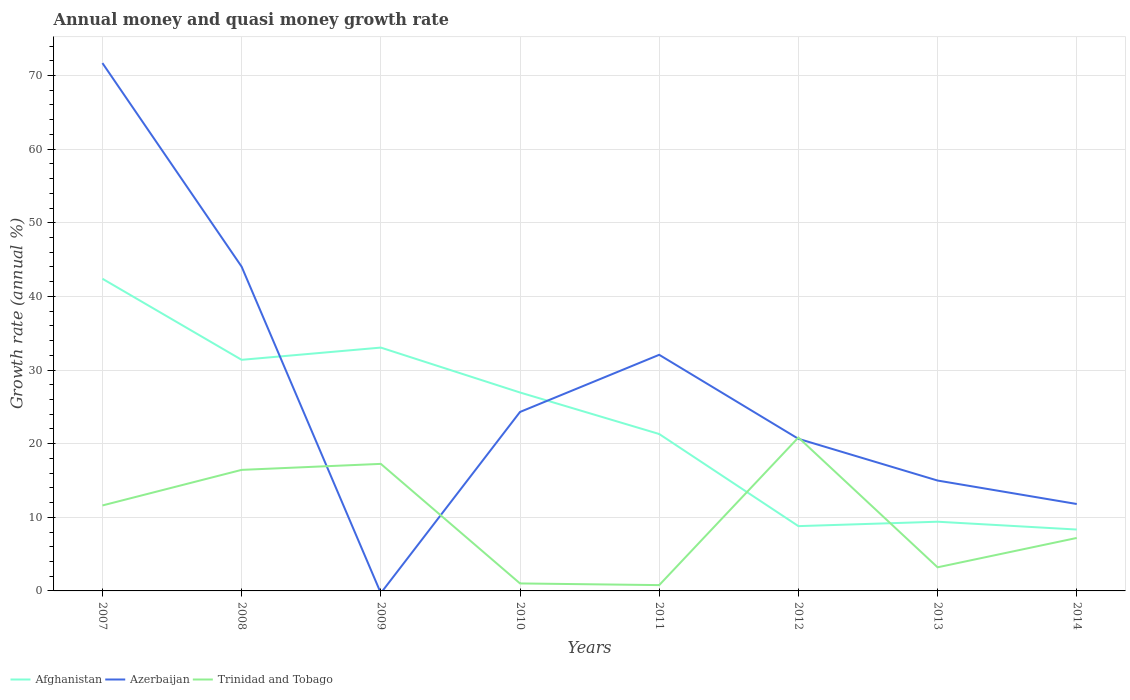Does the line corresponding to Trinidad and Tobago intersect with the line corresponding to Afghanistan?
Ensure brevity in your answer.  Yes. Is the number of lines equal to the number of legend labels?
Give a very brief answer. No. What is the total growth rate in Trinidad and Tobago in the graph?
Your answer should be very brief. -4.83. What is the difference between the highest and the second highest growth rate in Trinidad and Tobago?
Provide a short and direct response. 20.04. What is the difference between the highest and the lowest growth rate in Trinidad and Tobago?
Your answer should be very brief. 4. What is the difference between two consecutive major ticks on the Y-axis?
Keep it short and to the point. 10. Are the values on the major ticks of Y-axis written in scientific E-notation?
Keep it short and to the point. No. Does the graph contain any zero values?
Your answer should be compact. Yes. Where does the legend appear in the graph?
Offer a very short reply. Bottom left. What is the title of the graph?
Your answer should be very brief. Annual money and quasi money growth rate. What is the label or title of the X-axis?
Keep it short and to the point. Years. What is the label or title of the Y-axis?
Ensure brevity in your answer.  Growth rate (annual %). What is the Growth rate (annual %) in Afghanistan in 2007?
Offer a very short reply. 42.4. What is the Growth rate (annual %) in Azerbaijan in 2007?
Provide a short and direct response. 71.68. What is the Growth rate (annual %) in Trinidad and Tobago in 2007?
Your answer should be very brief. 11.61. What is the Growth rate (annual %) of Afghanistan in 2008?
Your answer should be very brief. 31.38. What is the Growth rate (annual %) of Azerbaijan in 2008?
Provide a succinct answer. 44.04. What is the Growth rate (annual %) of Trinidad and Tobago in 2008?
Ensure brevity in your answer.  16.44. What is the Growth rate (annual %) of Afghanistan in 2009?
Your answer should be compact. 33.05. What is the Growth rate (annual %) of Trinidad and Tobago in 2009?
Offer a terse response. 17.25. What is the Growth rate (annual %) in Afghanistan in 2010?
Ensure brevity in your answer.  26.95. What is the Growth rate (annual %) in Azerbaijan in 2010?
Provide a succinct answer. 24.3. What is the Growth rate (annual %) in Trinidad and Tobago in 2010?
Keep it short and to the point. 1.02. What is the Growth rate (annual %) of Afghanistan in 2011?
Ensure brevity in your answer.  21.31. What is the Growth rate (annual %) in Azerbaijan in 2011?
Offer a very short reply. 32.07. What is the Growth rate (annual %) in Trinidad and Tobago in 2011?
Your answer should be very brief. 0.79. What is the Growth rate (annual %) of Afghanistan in 2012?
Give a very brief answer. 8.8. What is the Growth rate (annual %) of Azerbaijan in 2012?
Give a very brief answer. 20.66. What is the Growth rate (annual %) of Trinidad and Tobago in 2012?
Offer a terse response. 20.83. What is the Growth rate (annual %) of Afghanistan in 2013?
Ensure brevity in your answer.  9.4. What is the Growth rate (annual %) in Azerbaijan in 2013?
Your response must be concise. 14.99. What is the Growth rate (annual %) in Trinidad and Tobago in 2013?
Provide a succinct answer. 3.21. What is the Growth rate (annual %) in Afghanistan in 2014?
Provide a succinct answer. 8.34. What is the Growth rate (annual %) in Azerbaijan in 2014?
Keep it short and to the point. 11.8. What is the Growth rate (annual %) of Trinidad and Tobago in 2014?
Give a very brief answer. 7.2. Across all years, what is the maximum Growth rate (annual %) of Afghanistan?
Your answer should be compact. 42.4. Across all years, what is the maximum Growth rate (annual %) in Azerbaijan?
Offer a terse response. 71.68. Across all years, what is the maximum Growth rate (annual %) of Trinidad and Tobago?
Your answer should be very brief. 20.83. Across all years, what is the minimum Growth rate (annual %) of Afghanistan?
Your response must be concise. 8.34. Across all years, what is the minimum Growth rate (annual %) of Trinidad and Tobago?
Your response must be concise. 0.79. What is the total Growth rate (annual %) of Afghanistan in the graph?
Your response must be concise. 181.61. What is the total Growth rate (annual %) in Azerbaijan in the graph?
Your response must be concise. 219.54. What is the total Growth rate (annual %) in Trinidad and Tobago in the graph?
Offer a terse response. 78.34. What is the difference between the Growth rate (annual %) of Afghanistan in 2007 and that in 2008?
Offer a terse response. 11.01. What is the difference between the Growth rate (annual %) in Azerbaijan in 2007 and that in 2008?
Provide a succinct answer. 27.65. What is the difference between the Growth rate (annual %) in Trinidad and Tobago in 2007 and that in 2008?
Offer a terse response. -4.83. What is the difference between the Growth rate (annual %) in Afghanistan in 2007 and that in 2009?
Make the answer very short. 9.35. What is the difference between the Growth rate (annual %) in Trinidad and Tobago in 2007 and that in 2009?
Ensure brevity in your answer.  -5.65. What is the difference between the Growth rate (annual %) of Afghanistan in 2007 and that in 2010?
Provide a short and direct response. 15.45. What is the difference between the Growth rate (annual %) in Azerbaijan in 2007 and that in 2010?
Offer a very short reply. 47.38. What is the difference between the Growth rate (annual %) of Trinidad and Tobago in 2007 and that in 2010?
Offer a terse response. 10.59. What is the difference between the Growth rate (annual %) in Afghanistan in 2007 and that in 2011?
Give a very brief answer. 21.09. What is the difference between the Growth rate (annual %) in Azerbaijan in 2007 and that in 2011?
Your answer should be compact. 39.62. What is the difference between the Growth rate (annual %) in Trinidad and Tobago in 2007 and that in 2011?
Your response must be concise. 10.82. What is the difference between the Growth rate (annual %) in Afghanistan in 2007 and that in 2012?
Your response must be concise. 33.6. What is the difference between the Growth rate (annual %) in Azerbaijan in 2007 and that in 2012?
Your answer should be compact. 51.03. What is the difference between the Growth rate (annual %) in Trinidad and Tobago in 2007 and that in 2012?
Offer a very short reply. -9.22. What is the difference between the Growth rate (annual %) in Afghanistan in 2007 and that in 2013?
Offer a terse response. 33. What is the difference between the Growth rate (annual %) in Azerbaijan in 2007 and that in 2013?
Make the answer very short. 56.69. What is the difference between the Growth rate (annual %) in Afghanistan in 2007 and that in 2014?
Offer a terse response. 34.06. What is the difference between the Growth rate (annual %) of Azerbaijan in 2007 and that in 2014?
Provide a short and direct response. 59.88. What is the difference between the Growth rate (annual %) in Trinidad and Tobago in 2007 and that in 2014?
Make the answer very short. 4.41. What is the difference between the Growth rate (annual %) in Afghanistan in 2008 and that in 2009?
Ensure brevity in your answer.  -1.66. What is the difference between the Growth rate (annual %) in Trinidad and Tobago in 2008 and that in 2009?
Give a very brief answer. -0.82. What is the difference between the Growth rate (annual %) in Afghanistan in 2008 and that in 2010?
Ensure brevity in your answer.  4.44. What is the difference between the Growth rate (annual %) of Azerbaijan in 2008 and that in 2010?
Make the answer very short. 19.73. What is the difference between the Growth rate (annual %) of Trinidad and Tobago in 2008 and that in 2010?
Keep it short and to the point. 15.42. What is the difference between the Growth rate (annual %) of Afghanistan in 2008 and that in 2011?
Offer a very short reply. 10.07. What is the difference between the Growth rate (annual %) in Azerbaijan in 2008 and that in 2011?
Give a very brief answer. 11.97. What is the difference between the Growth rate (annual %) in Trinidad and Tobago in 2008 and that in 2011?
Give a very brief answer. 15.65. What is the difference between the Growth rate (annual %) of Afghanistan in 2008 and that in 2012?
Your response must be concise. 22.58. What is the difference between the Growth rate (annual %) of Azerbaijan in 2008 and that in 2012?
Ensure brevity in your answer.  23.38. What is the difference between the Growth rate (annual %) of Trinidad and Tobago in 2008 and that in 2012?
Your answer should be very brief. -4.39. What is the difference between the Growth rate (annual %) in Afghanistan in 2008 and that in 2013?
Your answer should be compact. 21.99. What is the difference between the Growth rate (annual %) in Azerbaijan in 2008 and that in 2013?
Ensure brevity in your answer.  29.05. What is the difference between the Growth rate (annual %) in Trinidad and Tobago in 2008 and that in 2013?
Offer a very short reply. 13.23. What is the difference between the Growth rate (annual %) of Afghanistan in 2008 and that in 2014?
Give a very brief answer. 23.05. What is the difference between the Growth rate (annual %) of Azerbaijan in 2008 and that in 2014?
Give a very brief answer. 32.23. What is the difference between the Growth rate (annual %) of Trinidad and Tobago in 2008 and that in 2014?
Your response must be concise. 9.24. What is the difference between the Growth rate (annual %) of Afghanistan in 2009 and that in 2010?
Make the answer very short. 6.1. What is the difference between the Growth rate (annual %) of Trinidad and Tobago in 2009 and that in 2010?
Keep it short and to the point. 16.24. What is the difference between the Growth rate (annual %) in Afghanistan in 2009 and that in 2011?
Give a very brief answer. 11.74. What is the difference between the Growth rate (annual %) in Trinidad and Tobago in 2009 and that in 2011?
Offer a terse response. 16.46. What is the difference between the Growth rate (annual %) of Afghanistan in 2009 and that in 2012?
Your answer should be very brief. 24.25. What is the difference between the Growth rate (annual %) in Trinidad and Tobago in 2009 and that in 2012?
Give a very brief answer. -3.58. What is the difference between the Growth rate (annual %) in Afghanistan in 2009 and that in 2013?
Your answer should be compact. 23.65. What is the difference between the Growth rate (annual %) of Trinidad and Tobago in 2009 and that in 2013?
Your answer should be compact. 14.05. What is the difference between the Growth rate (annual %) in Afghanistan in 2009 and that in 2014?
Offer a very short reply. 24.71. What is the difference between the Growth rate (annual %) in Trinidad and Tobago in 2009 and that in 2014?
Make the answer very short. 10.06. What is the difference between the Growth rate (annual %) of Afghanistan in 2010 and that in 2011?
Make the answer very short. 5.64. What is the difference between the Growth rate (annual %) of Azerbaijan in 2010 and that in 2011?
Ensure brevity in your answer.  -7.76. What is the difference between the Growth rate (annual %) in Trinidad and Tobago in 2010 and that in 2011?
Ensure brevity in your answer.  0.23. What is the difference between the Growth rate (annual %) of Afghanistan in 2010 and that in 2012?
Provide a short and direct response. 18.15. What is the difference between the Growth rate (annual %) in Azerbaijan in 2010 and that in 2012?
Ensure brevity in your answer.  3.65. What is the difference between the Growth rate (annual %) in Trinidad and Tobago in 2010 and that in 2012?
Your response must be concise. -19.82. What is the difference between the Growth rate (annual %) of Afghanistan in 2010 and that in 2013?
Ensure brevity in your answer.  17.55. What is the difference between the Growth rate (annual %) of Azerbaijan in 2010 and that in 2013?
Your answer should be compact. 9.31. What is the difference between the Growth rate (annual %) of Trinidad and Tobago in 2010 and that in 2013?
Ensure brevity in your answer.  -2.19. What is the difference between the Growth rate (annual %) in Afghanistan in 2010 and that in 2014?
Provide a succinct answer. 18.61. What is the difference between the Growth rate (annual %) of Azerbaijan in 2010 and that in 2014?
Keep it short and to the point. 12.5. What is the difference between the Growth rate (annual %) of Trinidad and Tobago in 2010 and that in 2014?
Your answer should be compact. -6.18. What is the difference between the Growth rate (annual %) of Afghanistan in 2011 and that in 2012?
Give a very brief answer. 12.51. What is the difference between the Growth rate (annual %) of Azerbaijan in 2011 and that in 2012?
Make the answer very short. 11.41. What is the difference between the Growth rate (annual %) of Trinidad and Tobago in 2011 and that in 2012?
Make the answer very short. -20.04. What is the difference between the Growth rate (annual %) in Afghanistan in 2011 and that in 2013?
Offer a terse response. 11.91. What is the difference between the Growth rate (annual %) of Azerbaijan in 2011 and that in 2013?
Offer a very short reply. 17.08. What is the difference between the Growth rate (annual %) of Trinidad and Tobago in 2011 and that in 2013?
Provide a succinct answer. -2.42. What is the difference between the Growth rate (annual %) of Afghanistan in 2011 and that in 2014?
Your response must be concise. 12.97. What is the difference between the Growth rate (annual %) of Azerbaijan in 2011 and that in 2014?
Your answer should be compact. 20.26. What is the difference between the Growth rate (annual %) of Trinidad and Tobago in 2011 and that in 2014?
Give a very brief answer. -6.41. What is the difference between the Growth rate (annual %) in Afghanistan in 2012 and that in 2013?
Give a very brief answer. -0.6. What is the difference between the Growth rate (annual %) in Azerbaijan in 2012 and that in 2013?
Provide a succinct answer. 5.67. What is the difference between the Growth rate (annual %) in Trinidad and Tobago in 2012 and that in 2013?
Your response must be concise. 17.62. What is the difference between the Growth rate (annual %) in Afghanistan in 2012 and that in 2014?
Ensure brevity in your answer.  0.46. What is the difference between the Growth rate (annual %) in Azerbaijan in 2012 and that in 2014?
Offer a very short reply. 8.86. What is the difference between the Growth rate (annual %) of Trinidad and Tobago in 2012 and that in 2014?
Offer a very short reply. 13.64. What is the difference between the Growth rate (annual %) of Afghanistan in 2013 and that in 2014?
Provide a succinct answer. 1.06. What is the difference between the Growth rate (annual %) of Azerbaijan in 2013 and that in 2014?
Your answer should be very brief. 3.19. What is the difference between the Growth rate (annual %) of Trinidad and Tobago in 2013 and that in 2014?
Your response must be concise. -3.99. What is the difference between the Growth rate (annual %) of Afghanistan in 2007 and the Growth rate (annual %) of Azerbaijan in 2008?
Your answer should be compact. -1.64. What is the difference between the Growth rate (annual %) of Afghanistan in 2007 and the Growth rate (annual %) of Trinidad and Tobago in 2008?
Ensure brevity in your answer.  25.96. What is the difference between the Growth rate (annual %) in Azerbaijan in 2007 and the Growth rate (annual %) in Trinidad and Tobago in 2008?
Keep it short and to the point. 55.25. What is the difference between the Growth rate (annual %) in Afghanistan in 2007 and the Growth rate (annual %) in Trinidad and Tobago in 2009?
Keep it short and to the point. 25.14. What is the difference between the Growth rate (annual %) in Azerbaijan in 2007 and the Growth rate (annual %) in Trinidad and Tobago in 2009?
Give a very brief answer. 54.43. What is the difference between the Growth rate (annual %) of Afghanistan in 2007 and the Growth rate (annual %) of Azerbaijan in 2010?
Offer a very short reply. 18.09. What is the difference between the Growth rate (annual %) in Afghanistan in 2007 and the Growth rate (annual %) in Trinidad and Tobago in 2010?
Ensure brevity in your answer.  41.38. What is the difference between the Growth rate (annual %) in Azerbaijan in 2007 and the Growth rate (annual %) in Trinidad and Tobago in 2010?
Your answer should be compact. 70.67. What is the difference between the Growth rate (annual %) in Afghanistan in 2007 and the Growth rate (annual %) in Azerbaijan in 2011?
Offer a very short reply. 10.33. What is the difference between the Growth rate (annual %) of Afghanistan in 2007 and the Growth rate (annual %) of Trinidad and Tobago in 2011?
Make the answer very short. 41.61. What is the difference between the Growth rate (annual %) of Azerbaijan in 2007 and the Growth rate (annual %) of Trinidad and Tobago in 2011?
Your response must be concise. 70.89. What is the difference between the Growth rate (annual %) of Afghanistan in 2007 and the Growth rate (annual %) of Azerbaijan in 2012?
Provide a short and direct response. 21.74. What is the difference between the Growth rate (annual %) in Afghanistan in 2007 and the Growth rate (annual %) in Trinidad and Tobago in 2012?
Provide a succinct answer. 21.56. What is the difference between the Growth rate (annual %) of Azerbaijan in 2007 and the Growth rate (annual %) of Trinidad and Tobago in 2012?
Give a very brief answer. 50.85. What is the difference between the Growth rate (annual %) of Afghanistan in 2007 and the Growth rate (annual %) of Azerbaijan in 2013?
Make the answer very short. 27.41. What is the difference between the Growth rate (annual %) of Afghanistan in 2007 and the Growth rate (annual %) of Trinidad and Tobago in 2013?
Offer a terse response. 39.19. What is the difference between the Growth rate (annual %) in Azerbaijan in 2007 and the Growth rate (annual %) in Trinidad and Tobago in 2013?
Provide a short and direct response. 68.48. What is the difference between the Growth rate (annual %) in Afghanistan in 2007 and the Growth rate (annual %) in Azerbaijan in 2014?
Your response must be concise. 30.59. What is the difference between the Growth rate (annual %) in Afghanistan in 2007 and the Growth rate (annual %) in Trinidad and Tobago in 2014?
Offer a terse response. 35.2. What is the difference between the Growth rate (annual %) of Azerbaijan in 2007 and the Growth rate (annual %) of Trinidad and Tobago in 2014?
Your answer should be compact. 64.49. What is the difference between the Growth rate (annual %) in Afghanistan in 2008 and the Growth rate (annual %) in Trinidad and Tobago in 2009?
Make the answer very short. 14.13. What is the difference between the Growth rate (annual %) of Azerbaijan in 2008 and the Growth rate (annual %) of Trinidad and Tobago in 2009?
Offer a terse response. 26.78. What is the difference between the Growth rate (annual %) in Afghanistan in 2008 and the Growth rate (annual %) in Azerbaijan in 2010?
Offer a terse response. 7.08. What is the difference between the Growth rate (annual %) of Afghanistan in 2008 and the Growth rate (annual %) of Trinidad and Tobago in 2010?
Give a very brief answer. 30.37. What is the difference between the Growth rate (annual %) of Azerbaijan in 2008 and the Growth rate (annual %) of Trinidad and Tobago in 2010?
Provide a succinct answer. 43.02. What is the difference between the Growth rate (annual %) in Afghanistan in 2008 and the Growth rate (annual %) in Azerbaijan in 2011?
Your answer should be very brief. -0.68. What is the difference between the Growth rate (annual %) in Afghanistan in 2008 and the Growth rate (annual %) in Trinidad and Tobago in 2011?
Provide a short and direct response. 30.59. What is the difference between the Growth rate (annual %) of Azerbaijan in 2008 and the Growth rate (annual %) of Trinidad and Tobago in 2011?
Your answer should be compact. 43.25. What is the difference between the Growth rate (annual %) in Afghanistan in 2008 and the Growth rate (annual %) in Azerbaijan in 2012?
Provide a succinct answer. 10.73. What is the difference between the Growth rate (annual %) in Afghanistan in 2008 and the Growth rate (annual %) in Trinidad and Tobago in 2012?
Make the answer very short. 10.55. What is the difference between the Growth rate (annual %) of Azerbaijan in 2008 and the Growth rate (annual %) of Trinidad and Tobago in 2012?
Your answer should be very brief. 23.2. What is the difference between the Growth rate (annual %) in Afghanistan in 2008 and the Growth rate (annual %) in Azerbaijan in 2013?
Your answer should be very brief. 16.39. What is the difference between the Growth rate (annual %) in Afghanistan in 2008 and the Growth rate (annual %) in Trinidad and Tobago in 2013?
Provide a succinct answer. 28.18. What is the difference between the Growth rate (annual %) in Azerbaijan in 2008 and the Growth rate (annual %) in Trinidad and Tobago in 2013?
Your response must be concise. 40.83. What is the difference between the Growth rate (annual %) of Afghanistan in 2008 and the Growth rate (annual %) of Azerbaijan in 2014?
Your answer should be very brief. 19.58. What is the difference between the Growth rate (annual %) of Afghanistan in 2008 and the Growth rate (annual %) of Trinidad and Tobago in 2014?
Your response must be concise. 24.19. What is the difference between the Growth rate (annual %) in Azerbaijan in 2008 and the Growth rate (annual %) in Trinidad and Tobago in 2014?
Your response must be concise. 36.84. What is the difference between the Growth rate (annual %) of Afghanistan in 2009 and the Growth rate (annual %) of Azerbaijan in 2010?
Ensure brevity in your answer.  8.74. What is the difference between the Growth rate (annual %) of Afghanistan in 2009 and the Growth rate (annual %) of Trinidad and Tobago in 2010?
Offer a very short reply. 32.03. What is the difference between the Growth rate (annual %) in Afghanistan in 2009 and the Growth rate (annual %) in Azerbaijan in 2011?
Make the answer very short. 0.98. What is the difference between the Growth rate (annual %) of Afghanistan in 2009 and the Growth rate (annual %) of Trinidad and Tobago in 2011?
Offer a terse response. 32.26. What is the difference between the Growth rate (annual %) of Afghanistan in 2009 and the Growth rate (annual %) of Azerbaijan in 2012?
Your answer should be very brief. 12.39. What is the difference between the Growth rate (annual %) in Afghanistan in 2009 and the Growth rate (annual %) in Trinidad and Tobago in 2012?
Ensure brevity in your answer.  12.21. What is the difference between the Growth rate (annual %) of Afghanistan in 2009 and the Growth rate (annual %) of Azerbaijan in 2013?
Your response must be concise. 18.06. What is the difference between the Growth rate (annual %) in Afghanistan in 2009 and the Growth rate (annual %) in Trinidad and Tobago in 2013?
Ensure brevity in your answer.  29.84. What is the difference between the Growth rate (annual %) in Afghanistan in 2009 and the Growth rate (annual %) in Azerbaijan in 2014?
Provide a short and direct response. 21.24. What is the difference between the Growth rate (annual %) in Afghanistan in 2009 and the Growth rate (annual %) in Trinidad and Tobago in 2014?
Your answer should be compact. 25.85. What is the difference between the Growth rate (annual %) in Afghanistan in 2010 and the Growth rate (annual %) in Azerbaijan in 2011?
Your answer should be very brief. -5.12. What is the difference between the Growth rate (annual %) in Afghanistan in 2010 and the Growth rate (annual %) in Trinidad and Tobago in 2011?
Provide a succinct answer. 26.16. What is the difference between the Growth rate (annual %) of Azerbaijan in 2010 and the Growth rate (annual %) of Trinidad and Tobago in 2011?
Make the answer very short. 23.51. What is the difference between the Growth rate (annual %) of Afghanistan in 2010 and the Growth rate (annual %) of Azerbaijan in 2012?
Provide a succinct answer. 6.29. What is the difference between the Growth rate (annual %) in Afghanistan in 2010 and the Growth rate (annual %) in Trinidad and Tobago in 2012?
Offer a terse response. 6.11. What is the difference between the Growth rate (annual %) in Azerbaijan in 2010 and the Growth rate (annual %) in Trinidad and Tobago in 2012?
Your response must be concise. 3.47. What is the difference between the Growth rate (annual %) of Afghanistan in 2010 and the Growth rate (annual %) of Azerbaijan in 2013?
Ensure brevity in your answer.  11.96. What is the difference between the Growth rate (annual %) of Afghanistan in 2010 and the Growth rate (annual %) of Trinidad and Tobago in 2013?
Your answer should be compact. 23.74. What is the difference between the Growth rate (annual %) of Azerbaijan in 2010 and the Growth rate (annual %) of Trinidad and Tobago in 2013?
Provide a succinct answer. 21.1. What is the difference between the Growth rate (annual %) in Afghanistan in 2010 and the Growth rate (annual %) in Azerbaijan in 2014?
Your answer should be compact. 15.14. What is the difference between the Growth rate (annual %) of Afghanistan in 2010 and the Growth rate (annual %) of Trinidad and Tobago in 2014?
Provide a succinct answer. 19.75. What is the difference between the Growth rate (annual %) of Azerbaijan in 2010 and the Growth rate (annual %) of Trinidad and Tobago in 2014?
Ensure brevity in your answer.  17.11. What is the difference between the Growth rate (annual %) of Afghanistan in 2011 and the Growth rate (annual %) of Azerbaijan in 2012?
Offer a very short reply. 0.65. What is the difference between the Growth rate (annual %) in Afghanistan in 2011 and the Growth rate (annual %) in Trinidad and Tobago in 2012?
Make the answer very short. 0.48. What is the difference between the Growth rate (annual %) in Azerbaijan in 2011 and the Growth rate (annual %) in Trinidad and Tobago in 2012?
Your answer should be very brief. 11.23. What is the difference between the Growth rate (annual %) in Afghanistan in 2011 and the Growth rate (annual %) in Azerbaijan in 2013?
Your response must be concise. 6.32. What is the difference between the Growth rate (annual %) of Afghanistan in 2011 and the Growth rate (annual %) of Trinidad and Tobago in 2013?
Offer a terse response. 18.1. What is the difference between the Growth rate (annual %) of Azerbaijan in 2011 and the Growth rate (annual %) of Trinidad and Tobago in 2013?
Your answer should be very brief. 28.86. What is the difference between the Growth rate (annual %) in Afghanistan in 2011 and the Growth rate (annual %) in Azerbaijan in 2014?
Offer a terse response. 9.51. What is the difference between the Growth rate (annual %) of Afghanistan in 2011 and the Growth rate (annual %) of Trinidad and Tobago in 2014?
Keep it short and to the point. 14.11. What is the difference between the Growth rate (annual %) in Azerbaijan in 2011 and the Growth rate (annual %) in Trinidad and Tobago in 2014?
Ensure brevity in your answer.  24.87. What is the difference between the Growth rate (annual %) of Afghanistan in 2012 and the Growth rate (annual %) of Azerbaijan in 2013?
Your answer should be compact. -6.19. What is the difference between the Growth rate (annual %) of Afghanistan in 2012 and the Growth rate (annual %) of Trinidad and Tobago in 2013?
Keep it short and to the point. 5.59. What is the difference between the Growth rate (annual %) in Azerbaijan in 2012 and the Growth rate (annual %) in Trinidad and Tobago in 2013?
Give a very brief answer. 17.45. What is the difference between the Growth rate (annual %) in Afghanistan in 2012 and the Growth rate (annual %) in Azerbaijan in 2014?
Ensure brevity in your answer.  -3. What is the difference between the Growth rate (annual %) of Afghanistan in 2012 and the Growth rate (annual %) of Trinidad and Tobago in 2014?
Give a very brief answer. 1.61. What is the difference between the Growth rate (annual %) of Azerbaijan in 2012 and the Growth rate (annual %) of Trinidad and Tobago in 2014?
Provide a succinct answer. 13.46. What is the difference between the Growth rate (annual %) in Afghanistan in 2013 and the Growth rate (annual %) in Azerbaijan in 2014?
Your response must be concise. -2.41. What is the difference between the Growth rate (annual %) of Afghanistan in 2013 and the Growth rate (annual %) of Trinidad and Tobago in 2014?
Your response must be concise. 2.2. What is the difference between the Growth rate (annual %) in Azerbaijan in 2013 and the Growth rate (annual %) in Trinidad and Tobago in 2014?
Provide a short and direct response. 7.79. What is the average Growth rate (annual %) of Afghanistan per year?
Your response must be concise. 22.7. What is the average Growth rate (annual %) of Azerbaijan per year?
Your answer should be compact. 27.44. What is the average Growth rate (annual %) in Trinidad and Tobago per year?
Provide a short and direct response. 9.79. In the year 2007, what is the difference between the Growth rate (annual %) of Afghanistan and Growth rate (annual %) of Azerbaijan?
Ensure brevity in your answer.  -29.29. In the year 2007, what is the difference between the Growth rate (annual %) of Afghanistan and Growth rate (annual %) of Trinidad and Tobago?
Make the answer very short. 30.79. In the year 2007, what is the difference between the Growth rate (annual %) in Azerbaijan and Growth rate (annual %) in Trinidad and Tobago?
Your response must be concise. 60.08. In the year 2008, what is the difference between the Growth rate (annual %) in Afghanistan and Growth rate (annual %) in Azerbaijan?
Keep it short and to the point. -12.65. In the year 2008, what is the difference between the Growth rate (annual %) in Afghanistan and Growth rate (annual %) in Trinidad and Tobago?
Make the answer very short. 14.95. In the year 2008, what is the difference between the Growth rate (annual %) of Azerbaijan and Growth rate (annual %) of Trinidad and Tobago?
Offer a terse response. 27.6. In the year 2009, what is the difference between the Growth rate (annual %) in Afghanistan and Growth rate (annual %) in Trinidad and Tobago?
Give a very brief answer. 15.79. In the year 2010, what is the difference between the Growth rate (annual %) of Afghanistan and Growth rate (annual %) of Azerbaijan?
Ensure brevity in your answer.  2.64. In the year 2010, what is the difference between the Growth rate (annual %) in Afghanistan and Growth rate (annual %) in Trinidad and Tobago?
Your answer should be very brief. 25.93. In the year 2010, what is the difference between the Growth rate (annual %) of Azerbaijan and Growth rate (annual %) of Trinidad and Tobago?
Keep it short and to the point. 23.29. In the year 2011, what is the difference between the Growth rate (annual %) in Afghanistan and Growth rate (annual %) in Azerbaijan?
Your answer should be very brief. -10.76. In the year 2011, what is the difference between the Growth rate (annual %) of Afghanistan and Growth rate (annual %) of Trinidad and Tobago?
Your answer should be compact. 20.52. In the year 2011, what is the difference between the Growth rate (annual %) in Azerbaijan and Growth rate (annual %) in Trinidad and Tobago?
Provide a short and direct response. 31.28. In the year 2012, what is the difference between the Growth rate (annual %) of Afghanistan and Growth rate (annual %) of Azerbaijan?
Offer a terse response. -11.86. In the year 2012, what is the difference between the Growth rate (annual %) of Afghanistan and Growth rate (annual %) of Trinidad and Tobago?
Your answer should be very brief. -12.03. In the year 2012, what is the difference between the Growth rate (annual %) in Azerbaijan and Growth rate (annual %) in Trinidad and Tobago?
Keep it short and to the point. -0.17. In the year 2013, what is the difference between the Growth rate (annual %) in Afghanistan and Growth rate (annual %) in Azerbaijan?
Your answer should be compact. -5.59. In the year 2013, what is the difference between the Growth rate (annual %) of Afghanistan and Growth rate (annual %) of Trinidad and Tobago?
Your answer should be compact. 6.19. In the year 2013, what is the difference between the Growth rate (annual %) in Azerbaijan and Growth rate (annual %) in Trinidad and Tobago?
Your answer should be very brief. 11.78. In the year 2014, what is the difference between the Growth rate (annual %) of Afghanistan and Growth rate (annual %) of Azerbaijan?
Your answer should be compact. -3.47. In the year 2014, what is the difference between the Growth rate (annual %) of Afghanistan and Growth rate (annual %) of Trinidad and Tobago?
Your response must be concise. 1.14. In the year 2014, what is the difference between the Growth rate (annual %) of Azerbaijan and Growth rate (annual %) of Trinidad and Tobago?
Your response must be concise. 4.61. What is the ratio of the Growth rate (annual %) in Afghanistan in 2007 to that in 2008?
Your answer should be very brief. 1.35. What is the ratio of the Growth rate (annual %) in Azerbaijan in 2007 to that in 2008?
Offer a terse response. 1.63. What is the ratio of the Growth rate (annual %) of Trinidad and Tobago in 2007 to that in 2008?
Your answer should be very brief. 0.71. What is the ratio of the Growth rate (annual %) in Afghanistan in 2007 to that in 2009?
Provide a short and direct response. 1.28. What is the ratio of the Growth rate (annual %) of Trinidad and Tobago in 2007 to that in 2009?
Ensure brevity in your answer.  0.67. What is the ratio of the Growth rate (annual %) of Afghanistan in 2007 to that in 2010?
Provide a short and direct response. 1.57. What is the ratio of the Growth rate (annual %) of Azerbaijan in 2007 to that in 2010?
Your response must be concise. 2.95. What is the ratio of the Growth rate (annual %) of Trinidad and Tobago in 2007 to that in 2010?
Your answer should be very brief. 11.41. What is the ratio of the Growth rate (annual %) of Afghanistan in 2007 to that in 2011?
Your response must be concise. 1.99. What is the ratio of the Growth rate (annual %) in Azerbaijan in 2007 to that in 2011?
Your answer should be compact. 2.24. What is the ratio of the Growth rate (annual %) in Trinidad and Tobago in 2007 to that in 2011?
Make the answer very short. 14.7. What is the ratio of the Growth rate (annual %) in Afghanistan in 2007 to that in 2012?
Keep it short and to the point. 4.82. What is the ratio of the Growth rate (annual %) in Azerbaijan in 2007 to that in 2012?
Your answer should be very brief. 3.47. What is the ratio of the Growth rate (annual %) of Trinidad and Tobago in 2007 to that in 2012?
Your answer should be compact. 0.56. What is the ratio of the Growth rate (annual %) in Afghanistan in 2007 to that in 2013?
Your answer should be very brief. 4.51. What is the ratio of the Growth rate (annual %) of Azerbaijan in 2007 to that in 2013?
Provide a succinct answer. 4.78. What is the ratio of the Growth rate (annual %) of Trinidad and Tobago in 2007 to that in 2013?
Provide a succinct answer. 3.62. What is the ratio of the Growth rate (annual %) in Afghanistan in 2007 to that in 2014?
Offer a terse response. 5.09. What is the ratio of the Growth rate (annual %) of Azerbaijan in 2007 to that in 2014?
Offer a very short reply. 6.07. What is the ratio of the Growth rate (annual %) of Trinidad and Tobago in 2007 to that in 2014?
Provide a short and direct response. 1.61. What is the ratio of the Growth rate (annual %) in Afghanistan in 2008 to that in 2009?
Offer a terse response. 0.95. What is the ratio of the Growth rate (annual %) of Trinidad and Tobago in 2008 to that in 2009?
Your response must be concise. 0.95. What is the ratio of the Growth rate (annual %) of Afghanistan in 2008 to that in 2010?
Your answer should be very brief. 1.16. What is the ratio of the Growth rate (annual %) of Azerbaijan in 2008 to that in 2010?
Your answer should be compact. 1.81. What is the ratio of the Growth rate (annual %) in Trinidad and Tobago in 2008 to that in 2010?
Make the answer very short. 16.16. What is the ratio of the Growth rate (annual %) in Afghanistan in 2008 to that in 2011?
Your response must be concise. 1.47. What is the ratio of the Growth rate (annual %) in Azerbaijan in 2008 to that in 2011?
Ensure brevity in your answer.  1.37. What is the ratio of the Growth rate (annual %) in Trinidad and Tobago in 2008 to that in 2011?
Your answer should be very brief. 20.82. What is the ratio of the Growth rate (annual %) in Afghanistan in 2008 to that in 2012?
Make the answer very short. 3.57. What is the ratio of the Growth rate (annual %) of Azerbaijan in 2008 to that in 2012?
Provide a succinct answer. 2.13. What is the ratio of the Growth rate (annual %) of Trinidad and Tobago in 2008 to that in 2012?
Give a very brief answer. 0.79. What is the ratio of the Growth rate (annual %) of Afghanistan in 2008 to that in 2013?
Your answer should be compact. 3.34. What is the ratio of the Growth rate (annual %) in Azerbaijan in 2008 to that in 2013?
Ensure brevity in your answer.  2.94. What is the ratio of the Growth rate (annual %) of Trinidad and Tobago in 2008 to that in 2013?
Your response must be concise. 5.12. What is the ratio of the Growth rate (annual %) in Afghanistan in 2008 to that in 2014?
Keep it short and to the point. 3.77. What is the ratio of the Growth rate (annual %) of Azerbaijan in 2008 to that in 2014?
Give a very brief answer. 3.73. What is the ratio of the Growth rate (annual %) of Trinidad and Tobago in 2008 to that in 2014?
Offer a terse response. 2.28. What is the ratio of the Growth rate (annual %) of Afghanistan in 2009 to that in 2010?
Make the answer very short. 1.23. What is the ratio of the Growth rate (annual %) in Trinidad and Tobago in 2009 to that in 2010?
Ensure brevity in your answer.  16.96. What is the ratio of the Growth rate (annual %) in Afghanistan in 2009 to that in 2011?
Offer a terse response. 1.55. What is the ratio of the Growth rate (annual %) in Trinidad and Tobago in 2009 to that in 2011?
Provide a short and direct response. 21.86. What is the ratio of the Growth rate (annual %) of Afghanistan in 2009 to that in 2012?
Provide a succinct answer. 3.76. What is the ratio of the Growth rate (annual %) in Trinidad and Tobago in 2009 to that in 2012?
Ensure brevity in your answer.  0.83. What is the ratio of the Growth rate (annual %) in Afghanistan in 2009 to that in 2013?
Give a very brief answer. 3.52. What is the ratio of the Growth rate (annual %) in Trinidad and Tobago in 2009 to that in 2013?
Give a very brief answer. 5.38. What is the ratio of the Growth rate (annual %) of Afghanistan in 2009 to that in 2014?
Make the answer very short. 3.96. What is the ratio of the Growth rate (annual %) in Trinidad and Tobago in 2009 to that in 2014?
Give a very brief answer. 2.4. What is the ratio of the Growth rate (annual %) of Afghanistan in 2010 to that in 2011?
Offer a very short reply. 1.26. What is the ratio of the Growth rate (annual %) of Azerbaijan in 2010 to that in 2011?
Provide a short and direct response. 0.76. What is the ratio of the Growth rate (annual %) of Trinidad and Tobago in 2010 to that in 2011?
Offer a very short reply. 1.29. What is the ratio of the Growth rate (annual %) of Afghanistan in 2010 to that in 2012?
Your response must be concise. 3.06. What is the ratio of the Growth rate (annual %) of Azerbaijan in 2010 to that in 2012?
Make the answer very short. 1.18. What is the ratio of the Growth rate (annual %) of Trinidad and Tobago in 2010 to that in 2012?
Your answer should be very brief. 0.05. What is the ratio of the Growth rate (annual %) in Afghanistan in 2010 to that in 2013?
Your response must be concise. 2.87. What is the ratio of the Growth rate (annual %) of Azerbaijan in 2010 to that in 2013?
Offer a very short reply. 1.62. What is the ratio of the Growth rate (annual %) in Trinidad and Tobago in 2010 to that in 2013?
Give a very brief answer. 0.32. What is the ratio of the Growth rate (annual %) of Afghanistan in 2010 to that in 2014?
Keep it short and to the point. 3.23. What is the ratio of the Growth rate (annual %) of Azerbaijan in 2010 to that in 2014?
Give a very brief answer. 2.06. What is the ratio of the Growth rate (annual %) in Trinidad and Tobago in 2010 to that in 2014?
Make the answer very short. 0.14. What is the ratio of the Growth rate (annual %) in Afghanistan in 2011 to that in 2012?
Offer a very short reply. 2.42. What is the ratio of the Growth rate (annual %) in Azerbaijan in 2011 to that in 2012?
Your answer should be very brief. 1.55. What is the ratio of the Growth rate (annual %) in Trinidad and Tobago in 2011 to that in 2012?
Provide a succinct answer. 0.04. What is the ratio of the Growth rate (annual %) in Afghanistan in 2011 to that in 2013?
Make the answer very short. 2.27. What is the ratio of the Growth rate (annual %) in Azerbaijan in 2011 to that in 2013?
Provide a short and direct response. 2.14. What is the ratio of the Growth rate (annual %) in Trinidad and Tobago in 2011 to that in 2013?
Give a very brief answer. 0.25. What is the ratio of the Growth rate (annual %) of Afghanistan in 2011 to that in 2014?
Your answer should be very brief. 2.56. What is the ratio of the Growth rate (annual %) in Azerbaijan in 2011 to that in 2014?
Ensure brevity in your answer.  2.72. What is the ratio of the Growth rate (annual %) in Trinidad and Tobago in 2011 to that in 2014?
Provide a succinct answer. 0.11. What is the ratio of the Growth rate (annual %) in Afghanistan in 2012 to that in 2013?
Provide a short and direct response. 0.94. What is the ratio of the Growth rate (annual %) in Azerbaijan in 2012 to that in 2013?
Give a very brief answer. 1.38. What is the ratio of the Growth rate (annual %) of Trinidad and Tobago in 2012 to that in 2013?
Your answer should be compact. 6.5. What is the ratio of the Growth rate (annual %) in Afghanistan in 2012 to that in 2014?
Your answer should be compact. 1.06. What is the ratio of the Growth rate (annual %) of Azerbaijan in 2012 to that in 2014?
Offer a terse response. 1.75. What is the ratio of the Growth rate (annual %) in Trinidad and Tobago in 2012 to that in 2014?
Your answer should be very brief. 2.9. What is the ratio of the Growth rate (annual %) of Afghanistan in 2013 to that in 2014?
Provide a short and direct response. 1.13. What is the ratio of the Growth rate (annual %) of Azerbaijan in 2013 to that in 2014?
Offer a very short reply. 1.27. What is the ratio of the Growth rate (annual %) in Trinidad and Tobago in 2013 to that in 2014?
Provide a succinct answer. 0.45. What is the difference between the highest and the second highest Growth rate (annual %) in Afghanistan?
Your answer should be compact. 9.35. What is the difference between the highest and the second highest Growth rate (annual %) in Azerbaijan?
Make the answer very short. 27.65. What is the difference between the highest and the second highest Growth rate (annual %) in Trinidad and Tobago?
Keep it short and to the point. 3.58. What is the difference between the highest and the lowest Growth rate (annual %) of Afghanistan?
Make the answer very short. 34.06. What is the difference between the highest and the lowest Growth rate (annual %) of Azerbaijan?
Ensure brevity in your answer.  71.68. What is the difference between the highest and the lowest Growth rate (annual %) in Trinidad and Tobago?
Your answer should be compact. 20.04. 